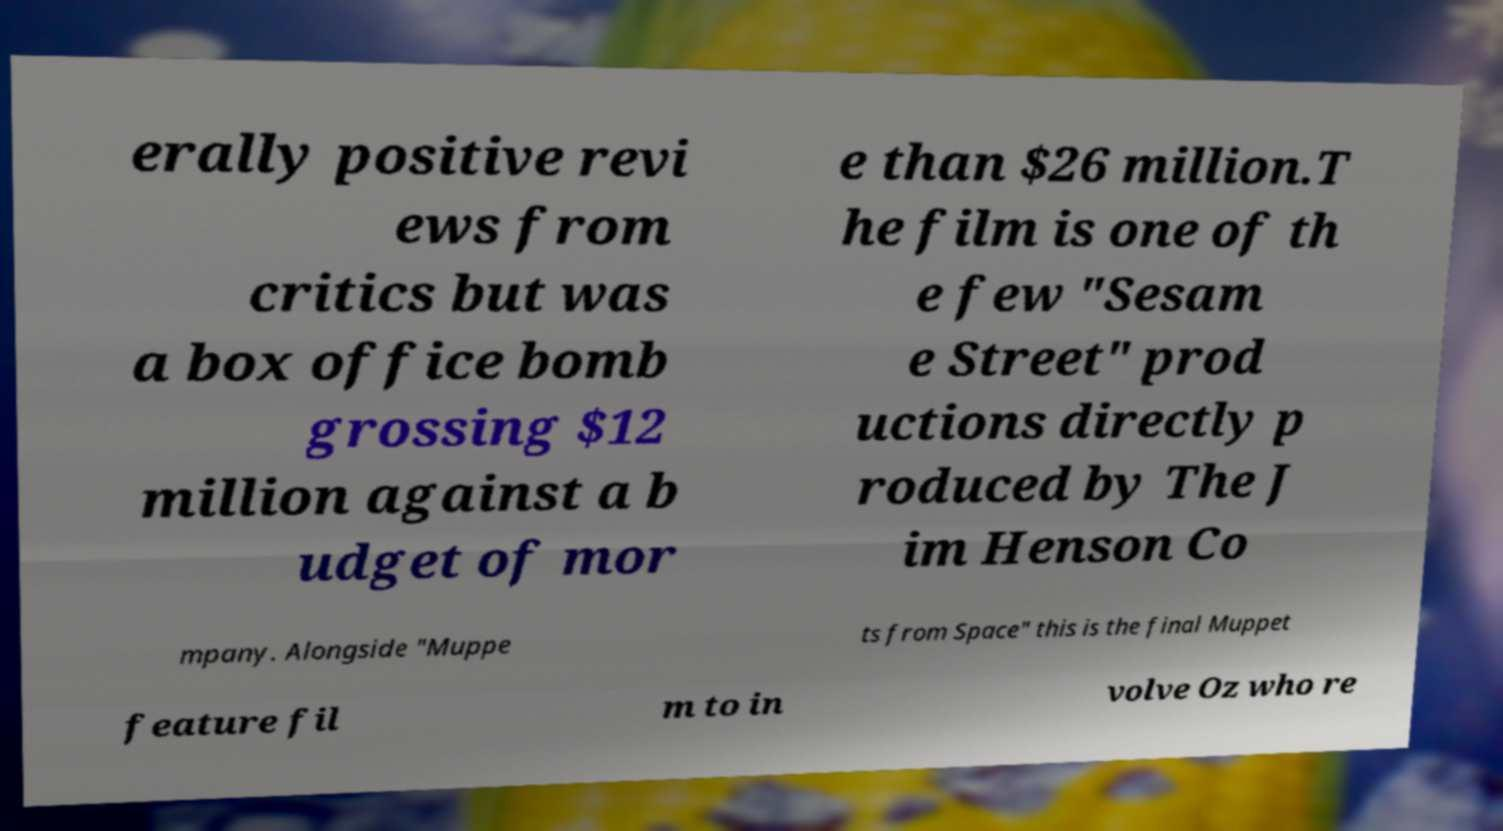Can you read and provide the text displayed in the image?This photo seems to have some interesting text. Can you extract and type it out for me? erally positive revi ews from critics but was a box office bomb grossing $12 million against a b udget of mor e than $26 million.T he film is one of th e few "Sesam e Street" prod uctions directly p roduced by The J im Henson Co mpany. Alongside "Muppe ts from Space" this is the final Muppet feature fil m to in volve Oz who re 